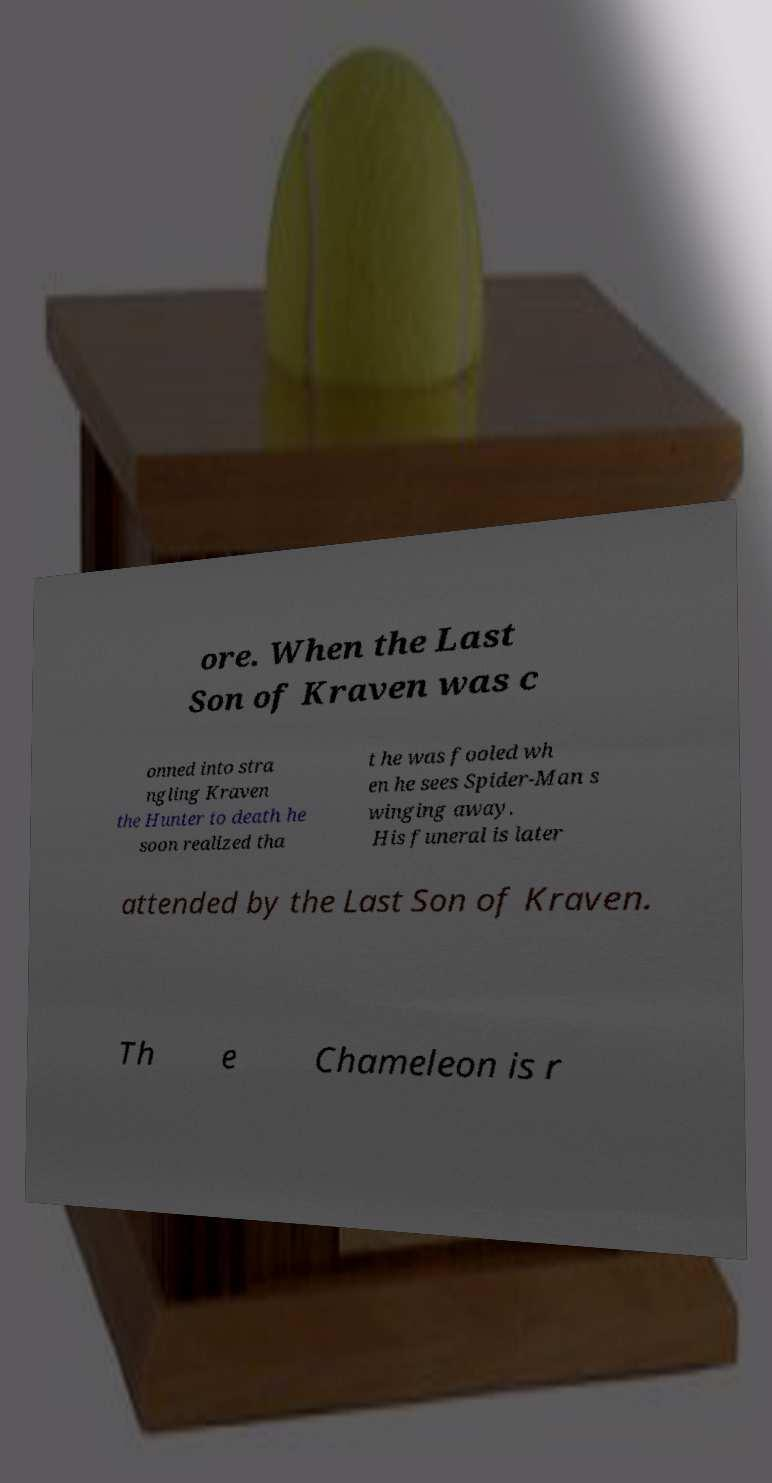Please identify and transcribe the text found in this image. ore. When the Last Son of Kraven was c onned into stra ngling Kraven the Hunter to death he soon realized tha t he was fooled wh en he sees Spider-Man s winging away. His funeral is later attended by the Last Son of Kraven. Th e Chameleon is r 